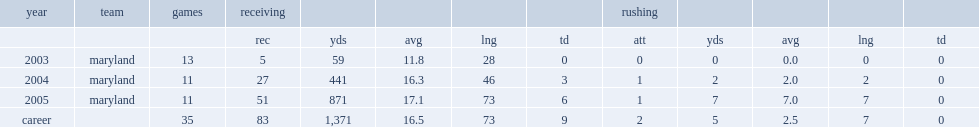How many receptions did vernon davis have for maryland in 2005? 51.0. 